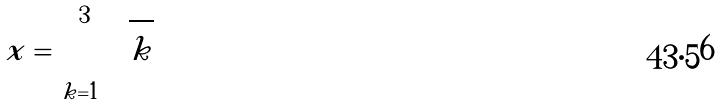<formula> <loc_0><loc_0><loc_500><loc_500>x = \sum _ { k = 1 } ^ { 3 } \sqrt { k }</formula> 